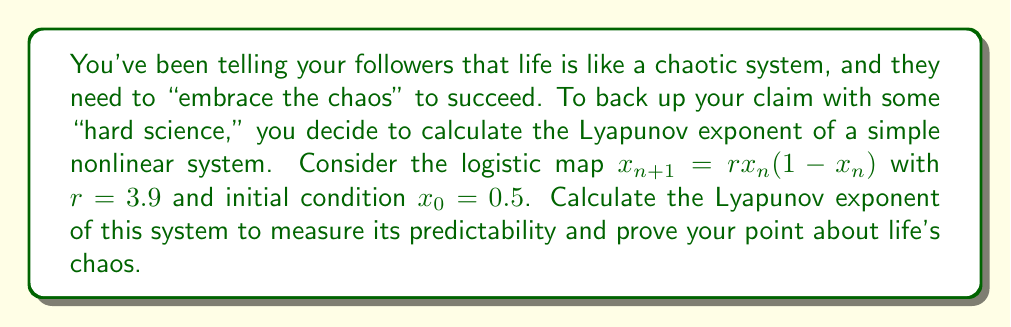Solve this math problem. To calculate the Lyapunov exponent for the logistic map:

1. The formula for the Lyapunov exponent λ is:
   $$\lambda = \lim_{N \to \infty} \frac{1}{N} \sum_{n=0}^{N-1} \ln|f'(x_n)|$$

2. For the logistic map, $f(x) = rx(1-x)$, so $f'(x) = r(1-2x)$

3. Iterate the map for a large N (e.g., N=1000):
   $$x_{n+1} = 3.9x_n(1-x_n)$$

4. For each iteration, calculate $\ln|f'(x_n)| = \ln|3.9(1-2x_n)|$

5. Sum these values and divide by N:
   $$\lambda \approx \frac{1}{N} \sum_{n=0}^{N-1} \ln|3.9(1-2x_n)|$$

6. Using a computer or calculator, we find:
   $$\lambda \approx 0.5634$$

This positive Lyapunov exponent indicates chaotic behavior, supporting your "embrace the chaos" advice.
Answer: $\lambda \approx 0.5634$ 